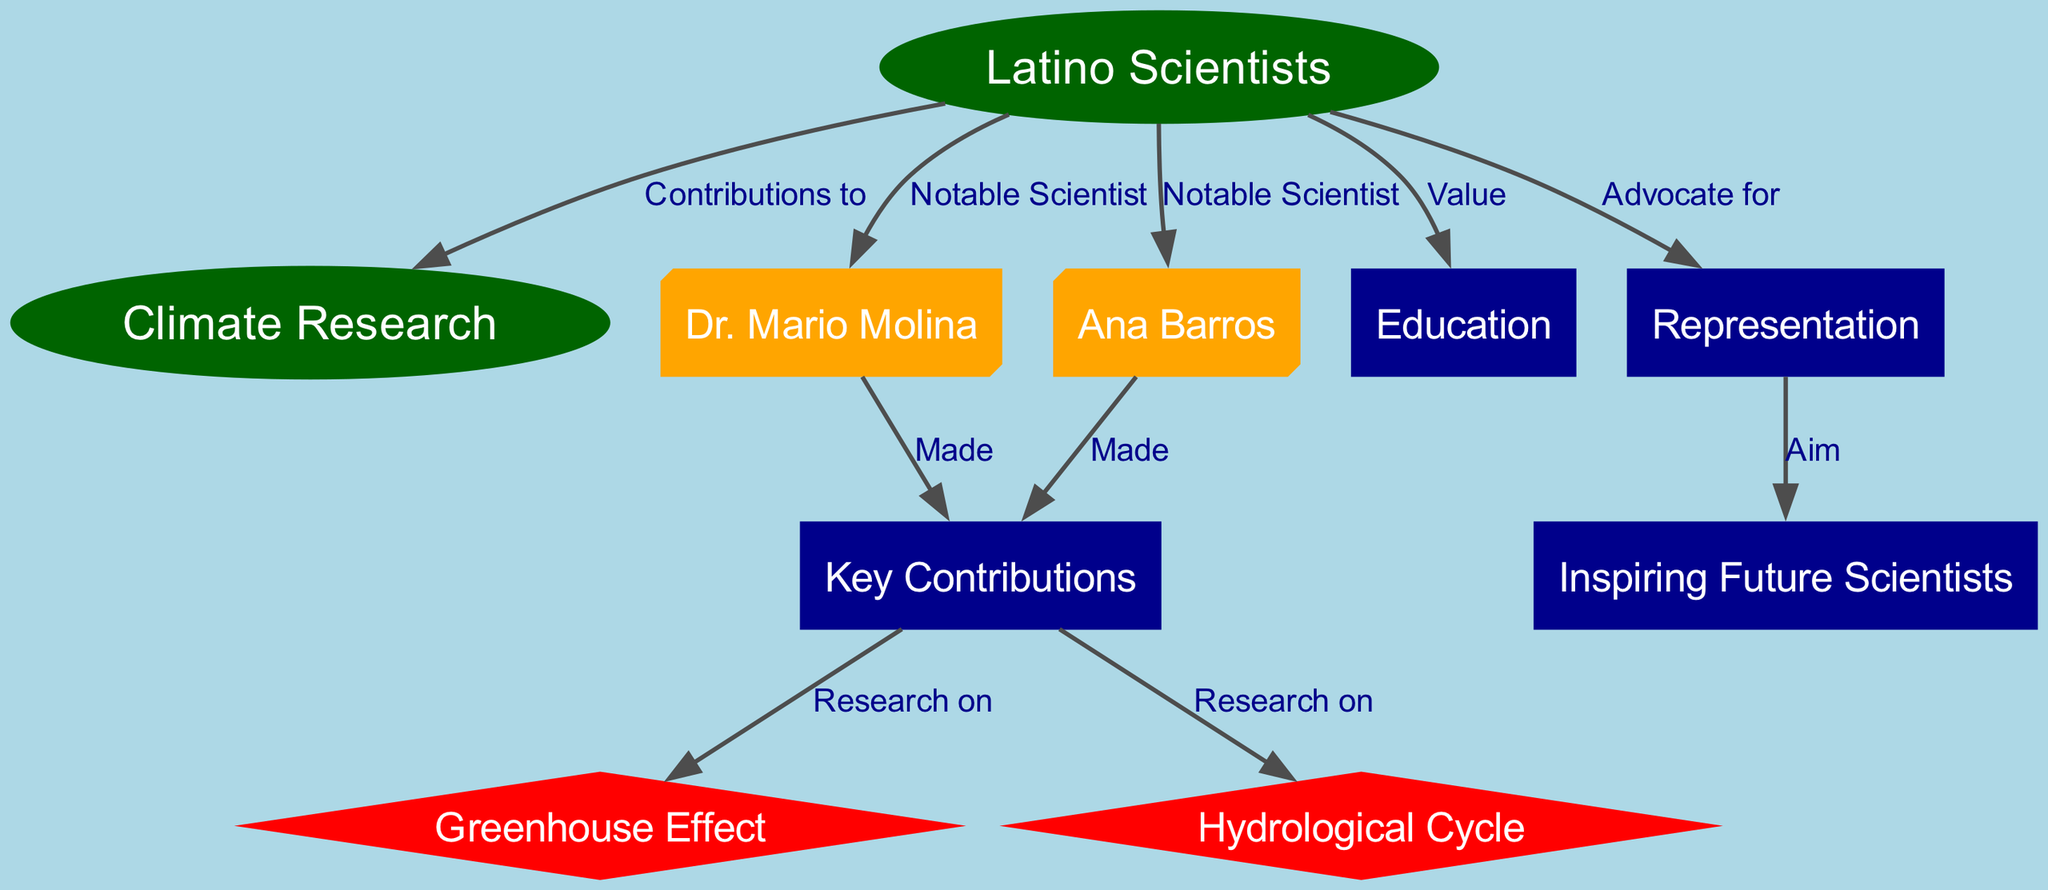What is the total number of nodes in the diagram? The diagram lists several nodes related to Latino scientists and their contributions to climate research. By counting the nodes provided, we find there are 10 distinct nodes.
Answer: 10 Who is a notable Latino scientist mentioned in the diagram? The diagram highlights several scientists, specifically mentioning Dr. Mario Molina and Ana Barros as notable Latino scientists.
Answer: Dr. Mario Molina What are two key areas of research conducted by Latino scientists according to the diagram? The edges in the diagram point to two specific areas of research, which are the Greenhouse Effect and the Hydrological Cycle. These are explicitly associated with Latino scientists’ contributions.
Answer: Greenhouse Effect, Hydrological Cycle What relationship exists between Latino scientists and climate research? According to the diagram, Latino scientists make contributions to climate research, as indicated by the directed edge connecting them.
Answer: Contributions to What is the aim of representation in the context of Latino scientists? The diagram indicates that the aim of representation for Latino scientists is to inspire future scientists, as shown by the connection through advocacy for representation that leads to inspiring future scientists.
Answer: Inspiring Future Scientists Which notable scientist is related to research on the Greenhouse Effect? The diagram shows that Dr. Mario Molina made key contributions that include research on the Greenhouse Effect. By following the edges, we can see this relationship.
Answer: Dr. Mario Molina How do Latino scientists value education according to the diagram? The diagram indicates Latino scientists value education, as shown by the relationship linking them directly to the concept of education within the structure presented.
Answer: Value Which node is connected directly to the representation node? The representation node directly connects to the node representing aspiring future scientists, illustrating the relationship between these concepts.
Answer: Inspiring Future Scientists 